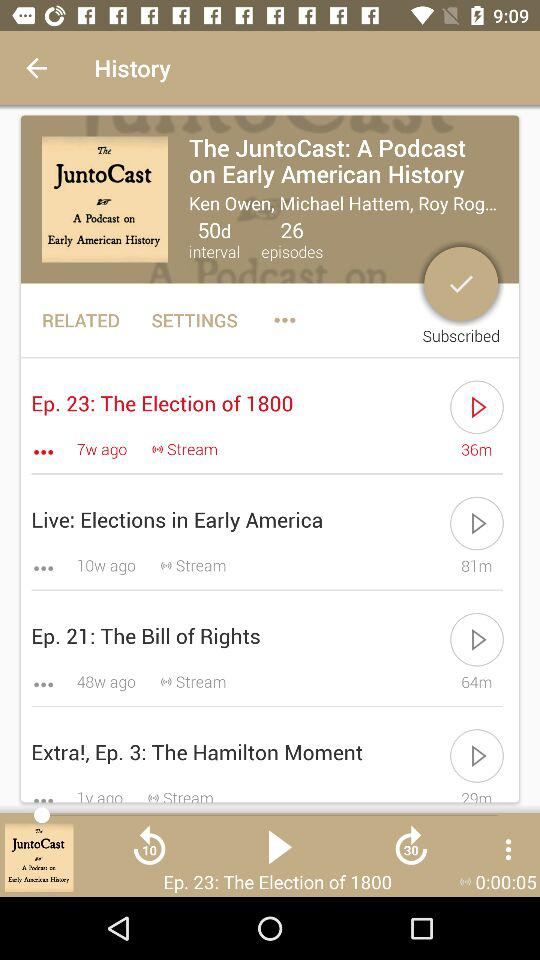What is the title of the podcast? The title of the podcast is "The JuntoCast: A Podcast on Early American History". 